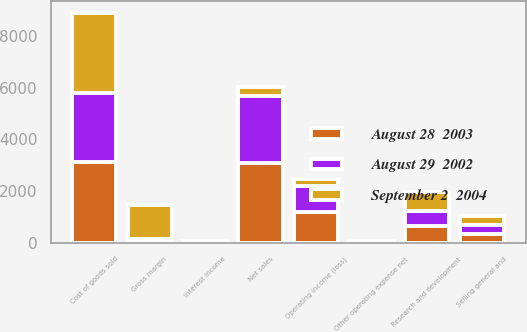Convert chart to OTSL. <chart><loc_0><loc_0><loc_500><loc_500><stacked_bar_chart><ecel><fcel>Net sales<fcel>Cost of goods sold<fcel>Gross margin<fcel>Selling general and<fcel>Research and development<fcel>Other operating expense net<fcel>Operating income (loss)<fcel>Interest income<nl><fcel>September 2  2004<fcel>358.2<fcel>3089.5<fcel>1314.7<fcel>332<fcel>754.9<fcel>0.6<fcel>249.7<fcel>15.2<nl><fcel>August 28  2003<fcel>3091.3<fcel>3112<fcel>20.7<fcel>358.2<fcel>656.4<fcel>42<fcel>1186.5<fcel>18.1<nl><fcel>August 29  2002<fcel>2589<fcel>2699.6<fcel>110.6<fcel>332.3<fcel>561.3<fcel>21.1<fcel>1025.3<fcel>51.6<nl></chart> 